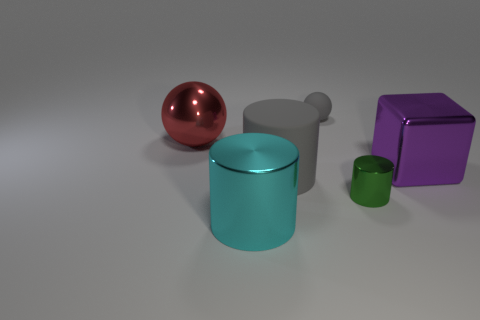Is the number of red things that are to the left of the metallic cube greater than the number of small yellow spheres?
Your answer should be compact. Yes. What number of rubber things are cyan cubes or gray cylinders?
Give a very brief answer. 1. There is a thing that is behind the purple object and in front of the gray rubber ball; what size is it?
Provide a short and direct response. Large. There is a cylinder behind the small shiny cylinder; are there any tiny spheres that are in front of it?
Provide a succinct answer. No. What number of large metallic objects are on the left side of the tiny gray matte sphere?
Offer a terse response. 2. There is a metal thing that is the same shape as the tiny gray matte thing; what color is it?
Your answer should be very brief. Red. Are the large purple object in front of the shiny ball and the tiny thing behind the purple block made of the same material?
Your answer should be compact. No. There is a shiny sphere; does it have the same color as the cylinder that is on the left side of the big rubber cylinder?
Offer a very short reply. No. There is a shiny object that is both behind the green cylinder and on the left side of the purple object; what shape is it?
Ensure brevity in your answer.  Sphere. How many tiny purple cubes are there?
Offer a terse response. 0. 